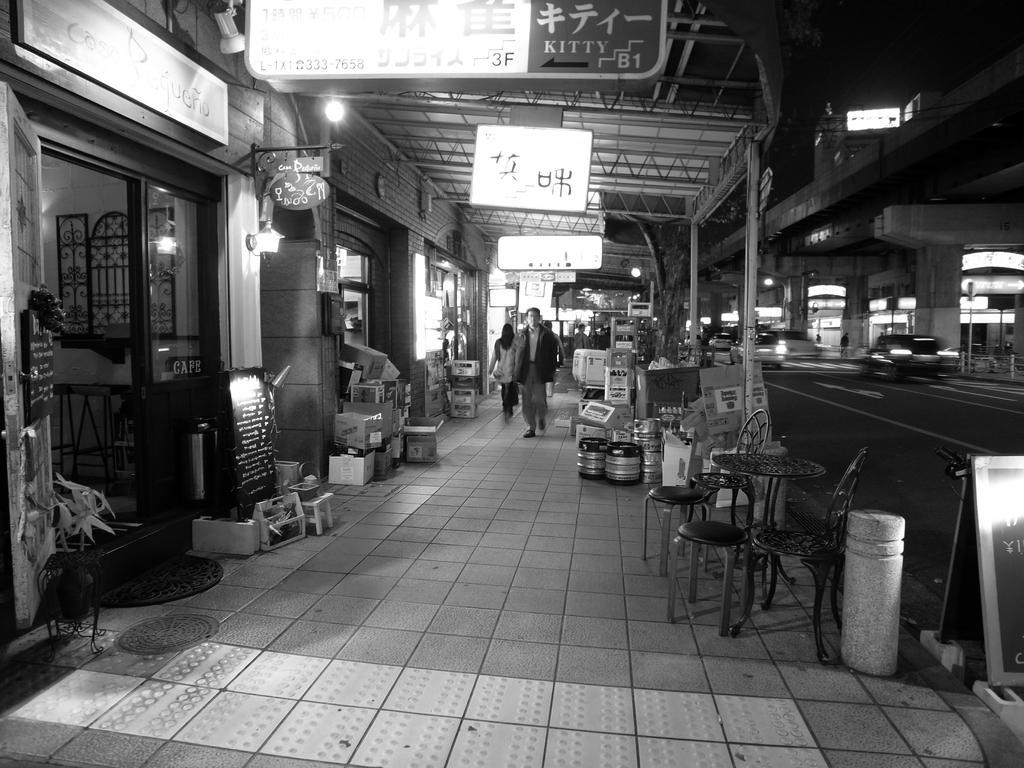In one or two sentences, can you explain what this image depicts? In the picture we can see some persons walking along the floor and there are some objects, tables, chairs on floor, we can see shops on left and right side of the picture, top of the picture there are some boards, there is roof. 